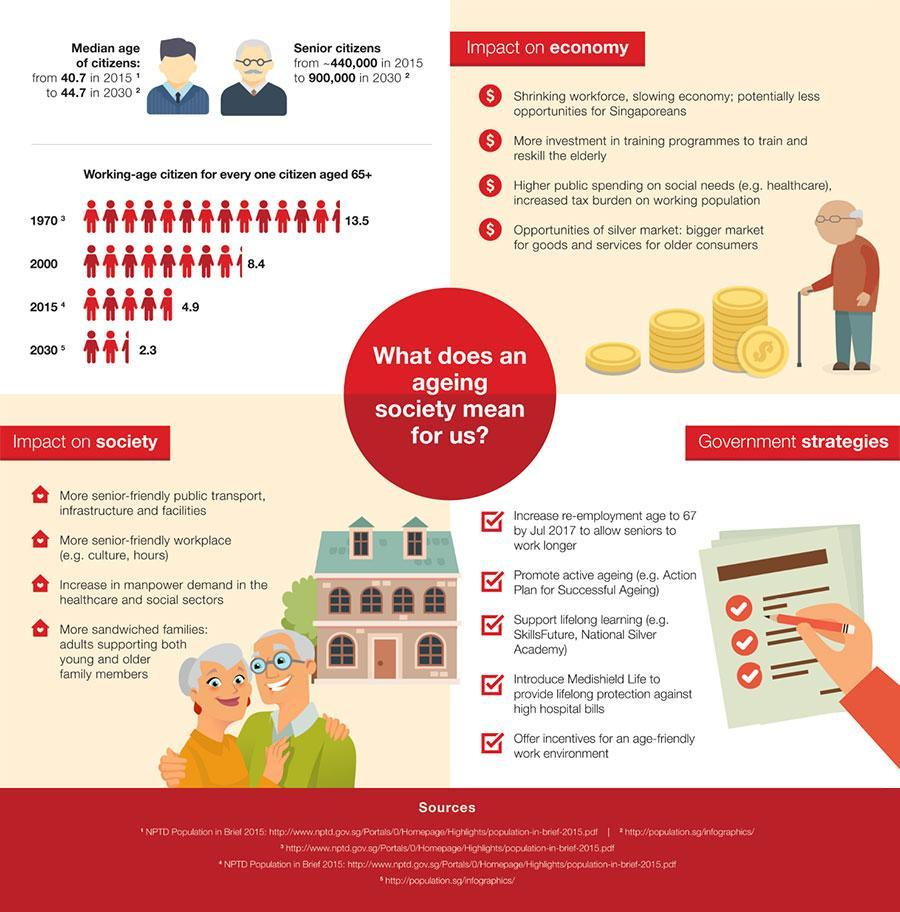How many points under the heading "Impact on economy"?
Answer the question with a short phrase. 4 How many points under the heading "Impact on society"? 4 How many points under the heading "Government Strategies"? 5 